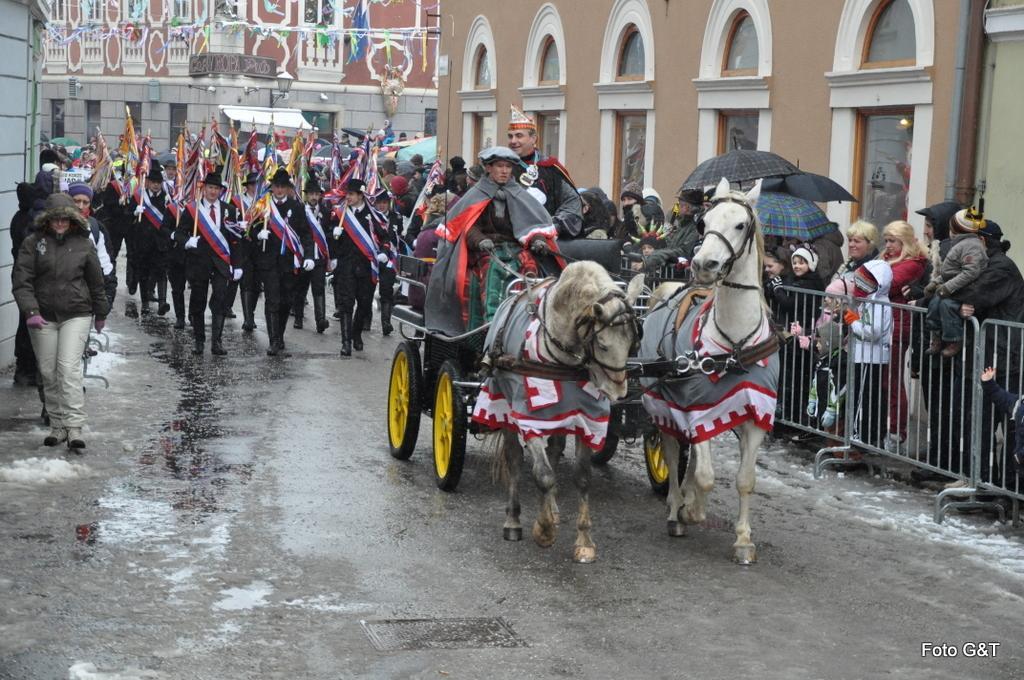Can you describe this image briefly? In this image, we can see persons in between buildings. There is a horse cart in the middle of the image. There are some persons holding flags with their hands. There are some other persons holding umbrellas with their hands. There are barricades on the right side of the image. 